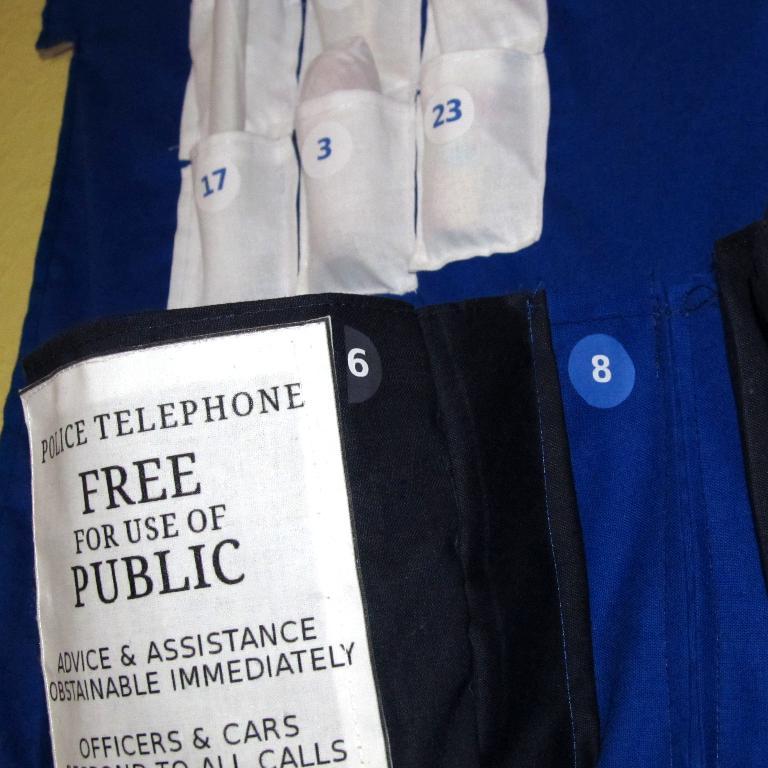How much does it cost to use this phone?
Offer a terse response. Free. What department does this phone belong to?
Provide a short and direct response. Police. 